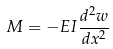<formula> <loc_0><loc_0><loc_500><loc_500>M = - E I \frac { d ^ { 2 } w } { d x ^ { 2 } }</formula> 